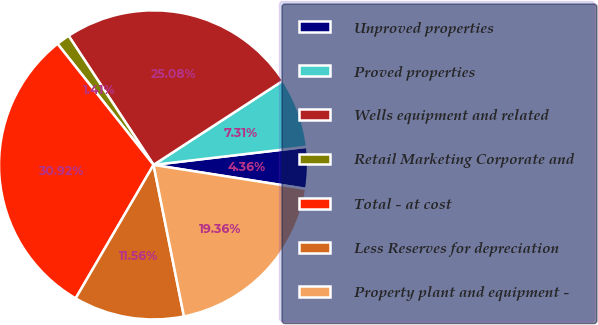<chart> <loc_0><loc_0><loc_500><loc_500><pie_chart><fcel>Unproved properties<fcel>Proved properties<fcel>Wells equipment and related<fcel>Retail Marketing Corporate and<fcel>Total - at cost<fcel>Less Reserves for depreciation<fcel>Property plant and equipment -<nl><fcel>4.36%<fcel>7.31%<fcel>25.08%<fcel>1.41%<fcel>30.92%<fcel>11.56%<fcel>19.36%<nl></chart> 